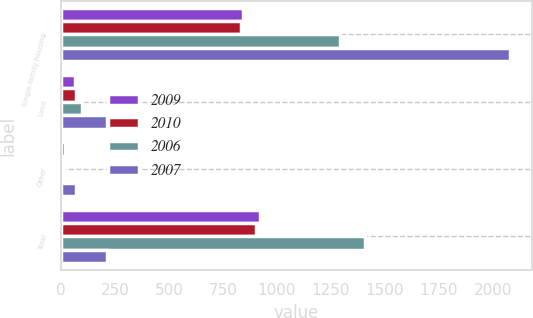Convert chart. <chart><loc_0><loc_0><loc_500><loc_500><stacked_bar_chart><ecel><fcel>Single-family housing<fcel>Land<fcel>Other<fcel>Total<nl><fcel>2009<fcel>842<fcel>64<fcel>17<fcel>923<nl><fcel>2010<fcel>832<fcel>68<fcel>4<fcel>904<nl><fcel>2006<fcel>1294<fcel>99<fcel>15<fcel>1408<nl><fcel>2007<fcel>2079<fcel>213<fcel>67<fcel>213<nl></chart> 